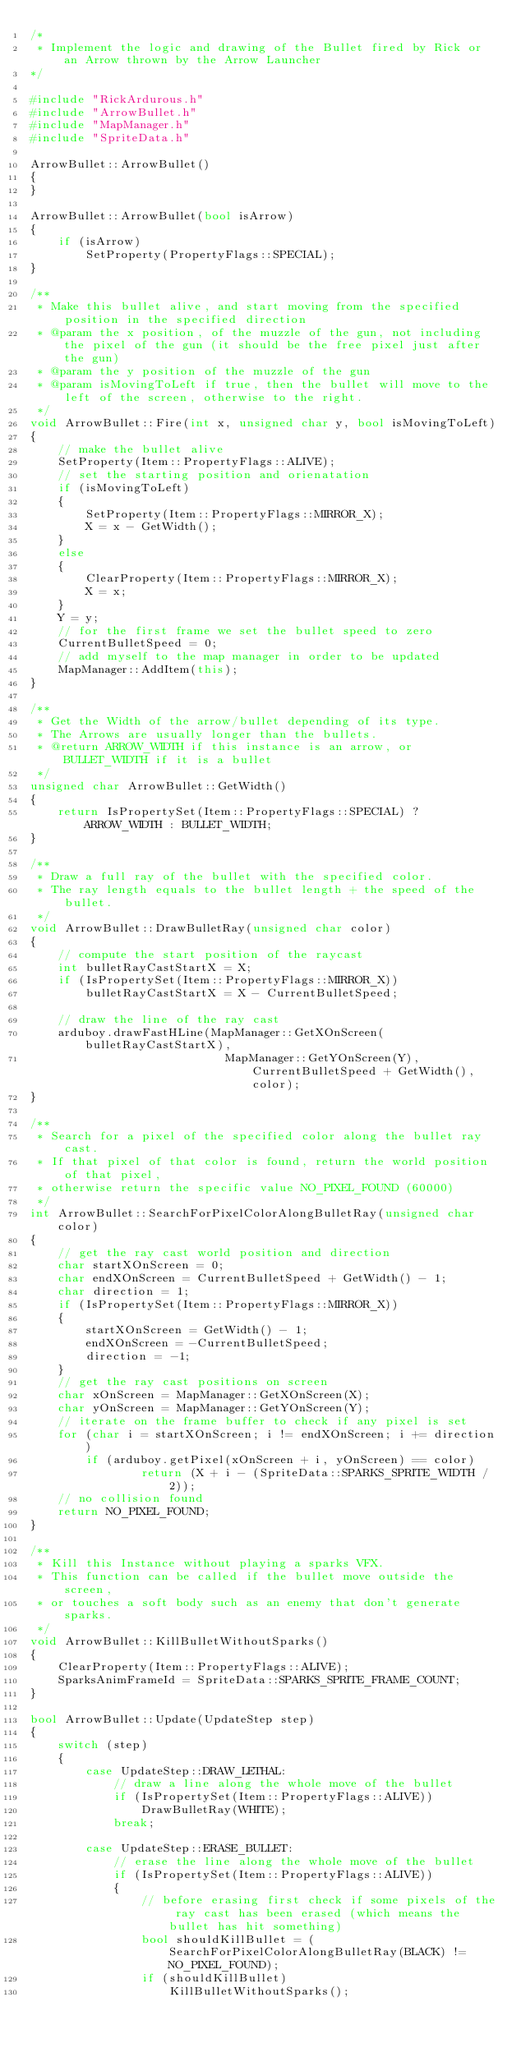<code> <loc_0><loc_0><loc_500><loc_500><_C++_>/*
 * Implement the logic and drawing of the Bullet fired by Rick or an Arrow thrown by the Arrow Launcher
*/

#include "RickArdurous.h"
#include "ArrowBullet.h"
#include "MapManager.h"
#include "SpriteData.h"

ArrowBullet::ArrowBullet()
{
}

ArrowBullet::ArrowBullet(bool isArrow)
{
	if (isArrow)
		SetProperty(PropertyFlags::SPECIAL);
}

/**
 * Make this bullet alive, and start moving from the specified position in the specified direction
 * @param the x position, of the muzzle of the gun, not including the pixel of the gun (it should be the free pixel just after the gun)
 * @param the y position of the muzzle of the gun
 * @param isMovingToLeft if true, then the bullet will move to the left of the screen, otherwise to the right.
 */
void ArrowBullet::Fire(int x, unsigned char y, bool isMovingToLeft)
{
	// make the bullet alive
	SetProperty(Item::PropertyFlags::ALIVE);
	// set the starting position and orienatation
	if (isMovingToLeft)
	{
		SetProperty(Item::PropertyFlags::MIRROR_X);
		X = x - GetWidth();
	}
	else
	{
		ClearProperty(Item::PropertyFlags::MIRROR_X);
		X = x;
	}
	Y = y;
	// for the first frame we set the bullet speed to zero
	CurrentBulletSpeed = 0;
	// add myself to the map manager in order to be updated
	MapManager::AddItem(this);
}

/**
 * Get the Width of the arrow/bullet depending of its type.
 * The Arrows are usually longer than the bullets.
 * @return ARROW_WIDTH if this instance is an arrow, or BULLET_WIDTH if it is a bullet
 */
unsigned char ArrowBullet::GetWidth()
{
	return IsPropertySet(Item::PropertyFlags::SPECIAL) ? ARROW_WIDTH : BULLET_WIDTH;
}

/**
 * Draw a full ray of the bullet with the specified color.
 * The ray length equals to the bullet length + the speed of the bullet.
 */
void ArrowBullet::DrawBulletRay(unsigned char color)
{
	// compute the start position of the raycast
	int bulletRayCastStartX = X;
	if (IsPropertySet(Item::PropertyFlags::MIRROR_X))
		bulletRayCastStartX = X - CurrentBulletSpeed;

	// draw the line of the ray cast
	arduboy.drawFastHLine(MapManager::GetXOnScreen(bulletRayCastStartX),
							MapManager::GetYOnScreen(Y), CurrentBulletSpeed + GetWidth(), color);
}

/**
 * Search for a pixel of the specified color along the bullet ray cast.
 * If that pixel of that color is found, return the world position of that pixel,
 * otherwise return the specific value NO_PIXEL_FOUND (60000)
 */
int ArrowBullet::SearchForPixelColorAlongBulletRay(unsigned char color)
{
	// get the ray cast world position and direction
	char startXOnScreen = 0;
	char endXOnScreen = CurrentBulletSpeed + GetWidth() - 1;
	char direction = 1;
	if (IsPropertySet(Item::PropertyFlags::MIRROR_X))
	{
		startXOnScreen = GetWidth() - 1;
		endXOnScreen = -CurrentBulletSpeed;
		direction = -1;
	}
	// get the ray cast positions on screen
	char xOnScreen = MapManager::GetXOnScreen(X);
	char yOnScreen = MapManager::GetYOnScreen(Y);
	// iterate on the frame buffer to check if any pixel is set
	for (char i = startXOnScreen; i != endXOnScreen; i += direction)
		if (arduboy.getPixel(xOnScreen + i, yOnScreen) == color)
				return (X + i - (SpriteData::SPARKS_SPRITE_WIDTH / 2));
	// no collision found
	return NO_PIXEL_FOUND;
}

/**
 * Kill this Instance without playing a sparks VFX.
 * This function can be called if the bullet move outside the screen,
 * or touches a soft body such as an enemy that don't generate sparks.
 */
void ArrowBullet::KillBulletWithoutSparks()
{
	ClearProperty(Item::PropertyFlags::ALIVE);
	SparksAnimFrameId = SpriteData::SPARKS_SPRITE_FRAME_COUNT;
}

bool ArrowBullet::Update(UpdateStep step)
{
	switch (step)
	{
		case UpdateStep::DRAW_LETHAL:
			// draw a line along the whole move of the bullet
			if (IsPropertySet(Item::PropertyFlags::ALIVE))
				DrawBulletRay(WHITE);
			break;

		case UpdateStep::ERASE_BULLET:
			// erase the line along the whole move of the bullet
			if (IsPropertySet(Item::PropertyFlags::ALIVE))
			{
				// before erasing first check if some pixels of the ray cast has been erased (which means the bullet has hit something)
				bool shouldKillBullet = (SearchForPixelColorAlongBulletRay(BLACK) != NO_PIXEL_FOUND);
				if (shouldKillBullet)
					KillBulletWithoutSparks();</code> 